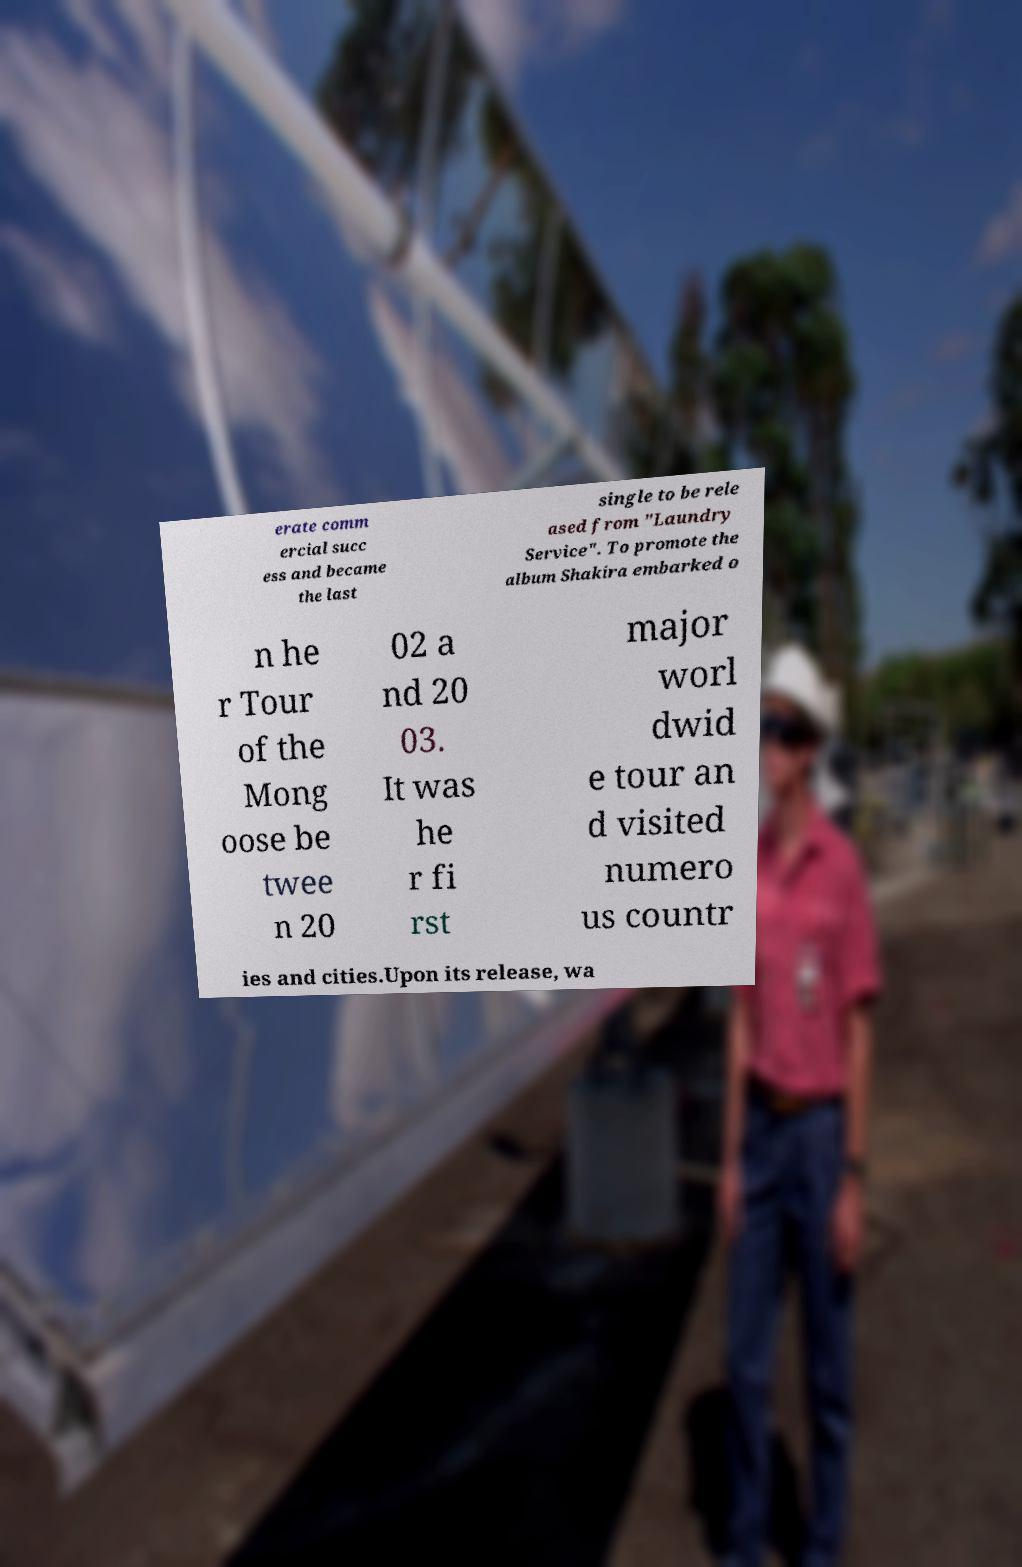Can you read and provide the text displayed in the image?This photo seems to have some interesting text. Can you extract and type it out for me? erate comm ercial succ ess and became the last single to be rele ased from "Laundry Service". To promote the album Shakira embarked o n he r Tour of the Mong oose be twee n 20 02 a nd 20 03. It was he r fi rst major worl dwid e tour an d visited numero us countr ies and cities.Upon its release, wa 